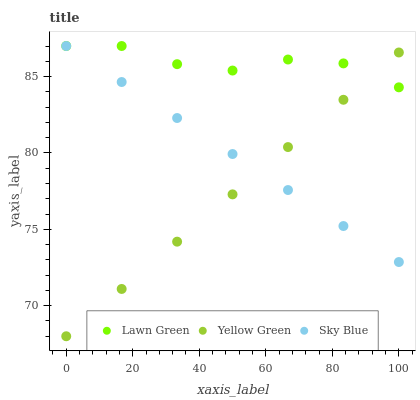Does Yellow Green have the minimum area under the curve?
Answer yes or no. Yes. Does Lawn Green have the maximum area under the curve?
Answer yes or no. Yes. Does Sky Blue have the minimum area under the curve?
Answer yes or no. No. Does Sky Blue have the maximum area under the curve?
Answer yes or no. No. Is Yellow Green the smoothest?
Answer yes or no. Yes. Is Lawn Green the roughest?
Answer yes or no. Yes. Is Sky Blue the smoothest?
Answer yes or no. No. Is Sky Blue the roughest?
Answer yes or no. No. Does Yellow Green have the lowest value?
Answer yes or no. Yes. Does Sky Blue have the lowest value?
Answer yes or no. No. Does Sky Blue have the highest value?
Answer yes or no. Yes. Does Yellow Green have the highest value?
Answer yes or no. No. Does Yellow Green intersect Sky Blue?
Answer yes or no. Yes. Is Yellow Green less than Sky Blue?
Answer yes or no. No. Is Yellow Green greater than Sky Blue?
Answer yes or no. No. 